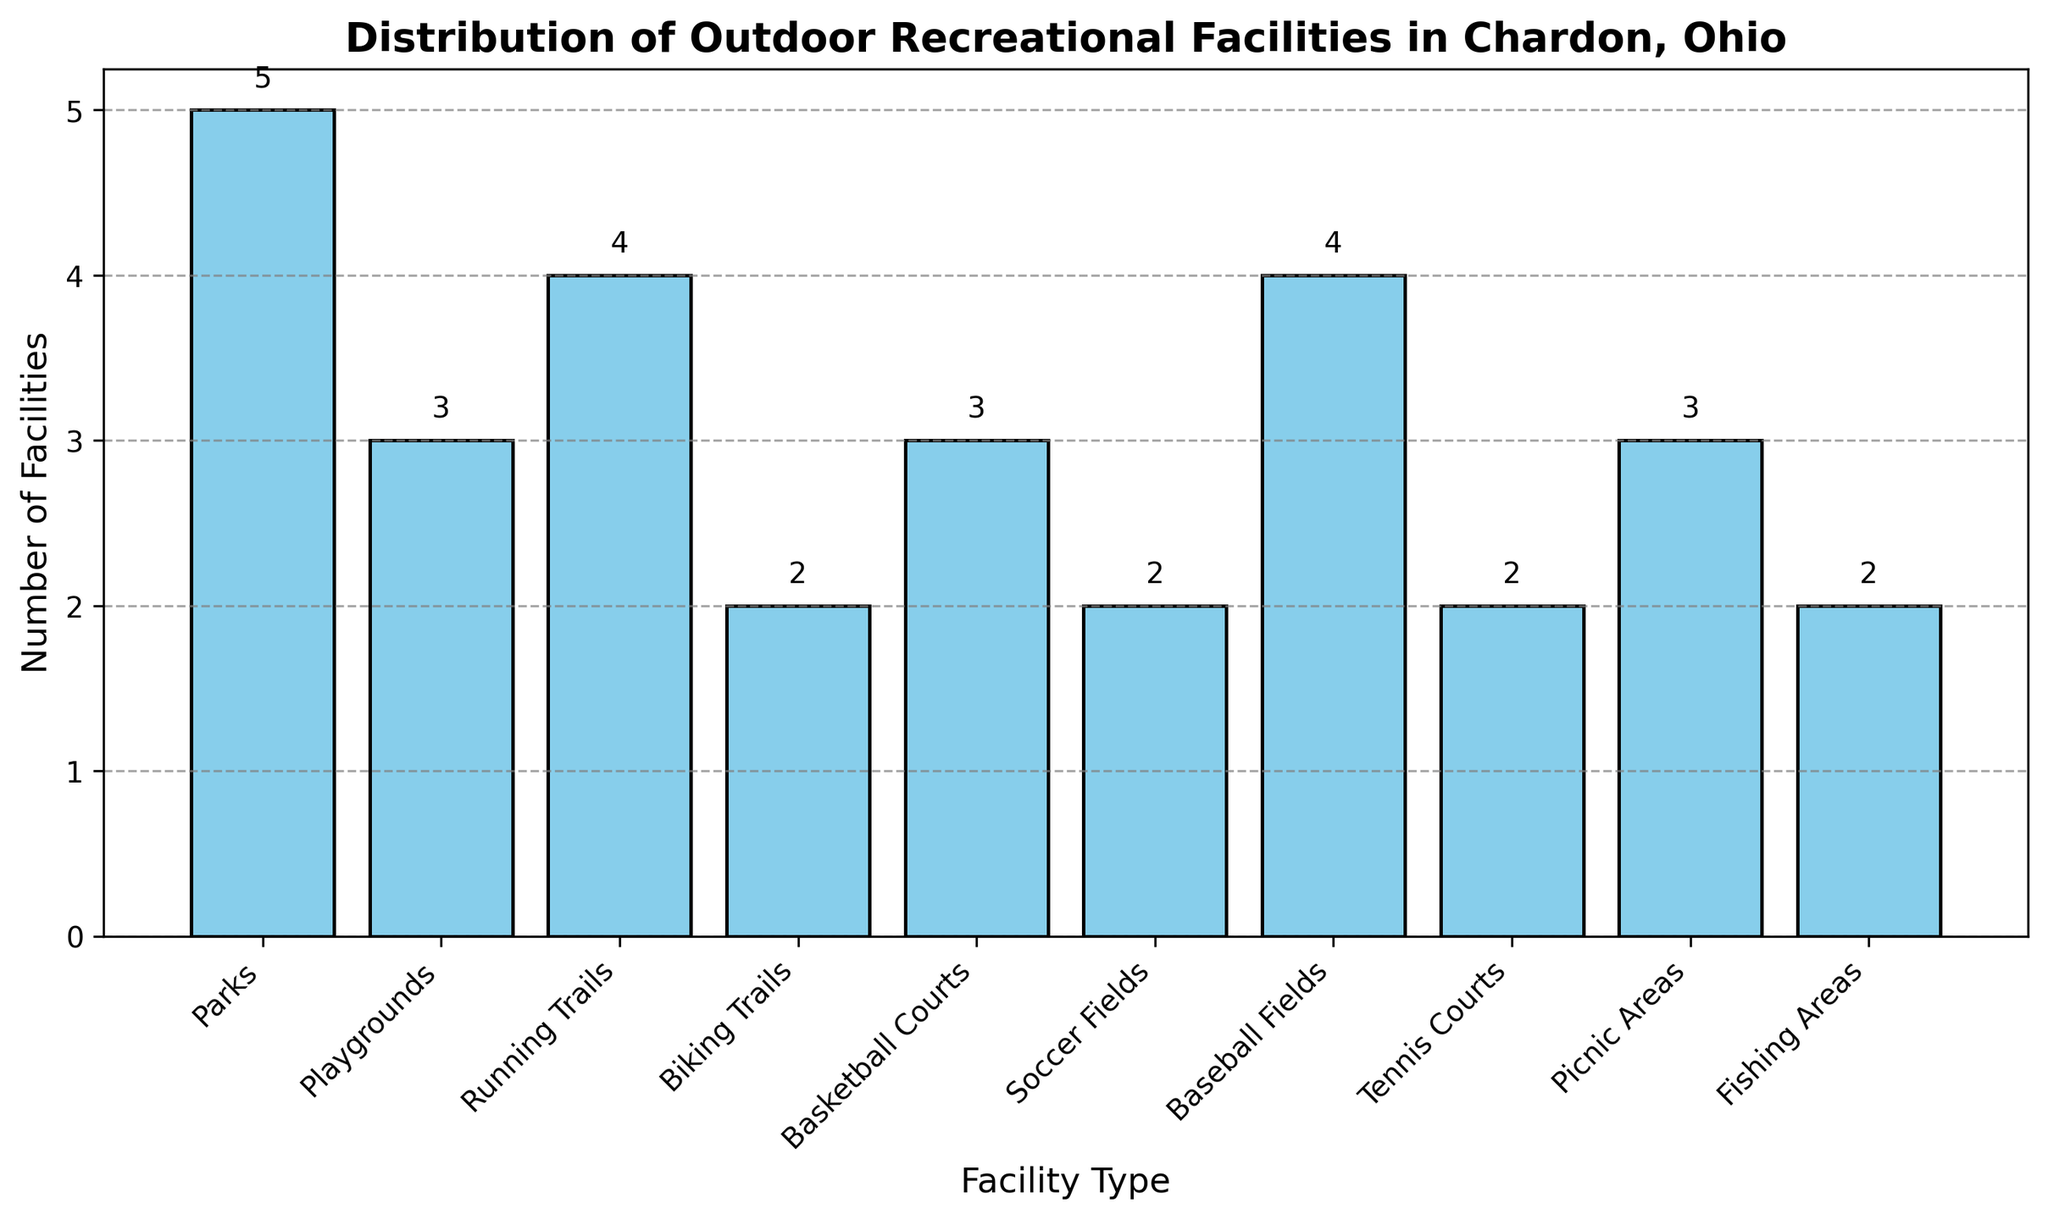Which facility type has the highest number of facilities? By looking at the height of the bars, the bar for “Parks” is the tallest, indicating it has the highest number of facilities.
Answer: Parks How many more baseball fields are there compared to biking trails? There are 4 baseball fields and 2 biking trails. Subtracting the number of biking trails from the number of baseball fields, 4 - 2 = 2.
Answer: 2 What's the total number of playgrounds, basketball courts, and picnic areas? Adding the number of playgrounds (3), basketball courts (3), and picnic areas (3), 3 + 3 + 3 = 9.
Answer: 9 Are there more running trails or fishing areas? By comparing the height of the bars, running trails have 4 facilities and fishing areas have 2 facilities.
Answer: Running trails Which two facility types have an equal number of facilities? From the bar heights, playgrounds and basketball courts both have 3 facilities each.
Answer: Playgrounds and Basketball Courts What's the average number of facilities for tennis courts, soccer fields, and fishing areas? Adding the number of tennis courts (2), soccer fields (2), and fishing areas (2), we get 2 + 2 + 2 = 6. Then, divide by 3, which is the number of facility types: 6 / 3 = 2.
Answer: 2 Are there more parks than the combined total of soccer fields and biking trails? Parks have 5 facilities. The combined total of soccer fields (2) and biking trails (2) is 2 + 2 = 4. 5 is greater than 4, so yes.
Answer: Yes What’s the difference in the number of facilities between the type with the most and the type with the fewest facilities? Parks have the most facilities (5), and multiple types (biking trails, soccer fields, tennis courts, fishing areas) have the fewest (2). The difference is 5 - 2 = 3.
Answer: 3 How many total outdoor recreational facilities are there? Sum the number of all facilities: 5 + 3 + 4 + 2 + 3 + 2 + 4 + 2 + 3 + 2 = 30.
Answer: 30 